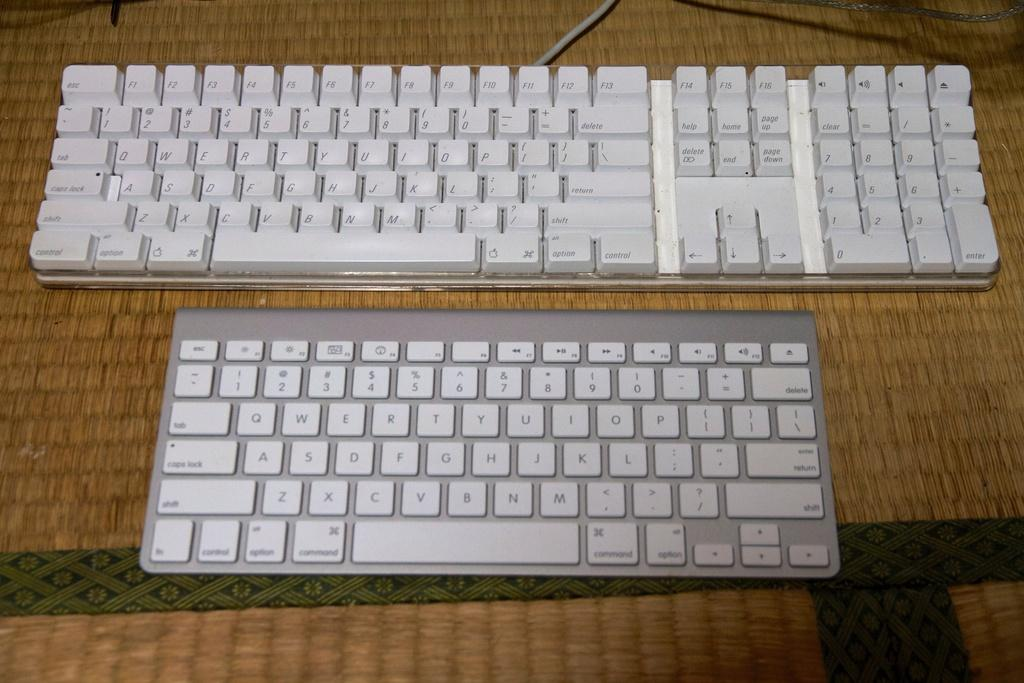Provide a one-sentence caption for the provided image. A bigger QWERT keyboard is next to a smaller keyboard on the table. 